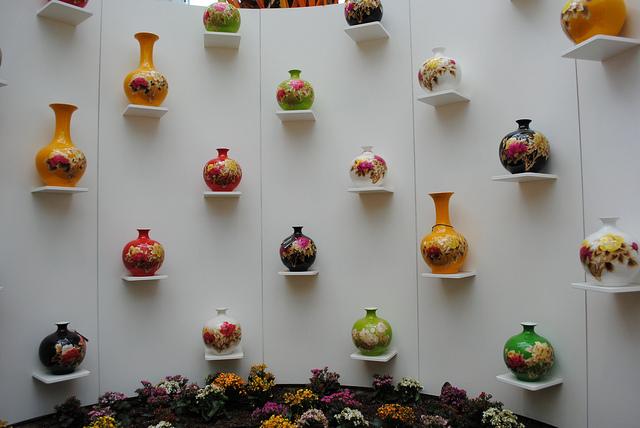Are objects in the picture vases?
Give a very brief answer. Yes. Do the bright colors in this picture give a festive appearance to the scene?
Keep it brief. Yes. What are the vases sitting on?
Keep it brief. Shelves. 